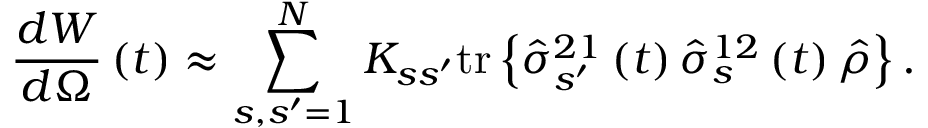<formula> <loc_0><loc_0><loc_500><loc_500>\frac { d W } { d \Omega } \left ( t \right ) \approx \sum _ { s , s ^ { \prime } = 1 } ^ { N } K _ { s s ^ { \prime } } t r \left \{ \hat { \sigma } _ { s ^ { \prime } } ^ { 2 1 } \left ( t \right ) \hat { \sigma } _ { s } ^ { 1 2 } \left ( t \right ) \hat { \rho } \right \} .</formula> 